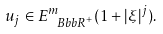<formula> <loc_0><loc_0><loc_500><loc_500>u _ { j } \in E ^ { m } _ { { \ B b b R } ^ { + } } ( 1 + | \xi | ^ { j } ) .</formula> 